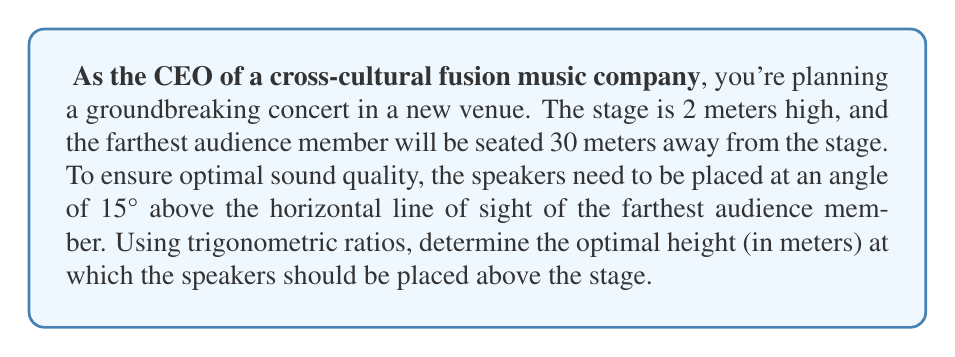Can you answer this question? To solve this problem, we need to use the tangent ratio in a right-angled triangle. Let's break it down step by step:

1. Visualize the scenario:
   [asy]
   import geometry;
   
   size(200);
   
   pair A = (0,0), B = (30,0), C = (30,2), D = (30,8);
   
   draw(A--B--D--A);
   draw(A--C, dashed);
   
   label("Stage", A, SW);
   label("Audience", B, SE);
   label("2m", (0,1), W);
   label("30m", (15,0), S);
   label("Speaker", D, E);
   label("15°", (0,2.5), NW);
   
   markangle(B,A,D,radius=3);
   [/asy]

2. We need to find the height of the speakers above the audience level, then add the stage height.

3. In the right-angled triangle formed by the speaker, the farthest audience member, and the vertical line from the speaker to the ground:
   - The adjacent side is 30 meters (distance to the farthest audience member)
   - The angle is 15°
   - We need to find the opposite side (height above audience level)

4. We can use the tangent ratio:
   $$ \tan(\theta) = \frac{\text{opposite}}{\text{adjacent}} $$

5. Plugging in our values:
   $$ \tan(15°) = \frac{h}{30} $$

6. Solving for h:
   $$ h = 30 \tan(15°) $$

7. Calculate:
   $$ h = 30 \times 0.2679 = 8.037 \text{ meters} $$

8. This is the height above the audience level. To get the total height, add the stage height:
   $$ \text{Total height} = 8.037 + 2 = 10.037 \text{ meters} $$

9. Rounding to two decimal places:
   $$ \text{Total height} \approx 10.04 \text{ meters} $$
Answer: The optimal height for the speakers is approximately 10.04 meters above the stage floor. 